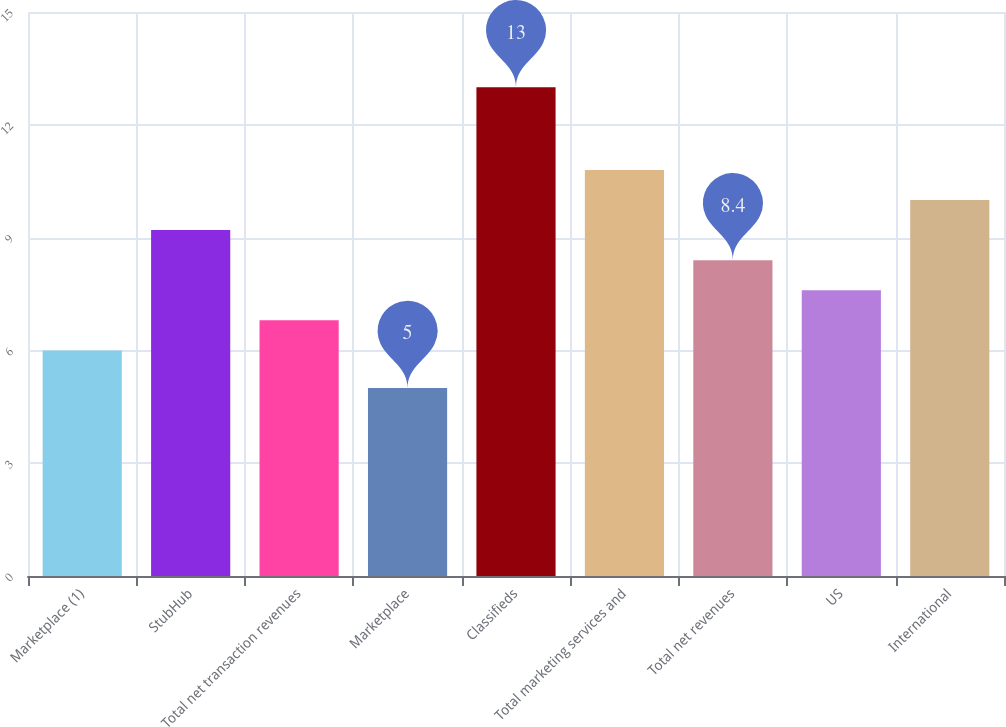<chart> <loc_0><loc_0><loc_500><loc_500><bar_chart><fcel>Marketplace (1)<fcel>StubHub<fcel>Total net transaction revenues<fcel>Marketplace<fcel>Classifieds<fcel>Total marketing services and<fcel>Total net revenues<fcel>US<fcel>International<nl><fcel>6<fcel>9.2<fcel>6.8<fcel>5<fcel>13<fcel>10.8<fcel>8.4<fcel>7.6<fcel>10<nl></chart> 